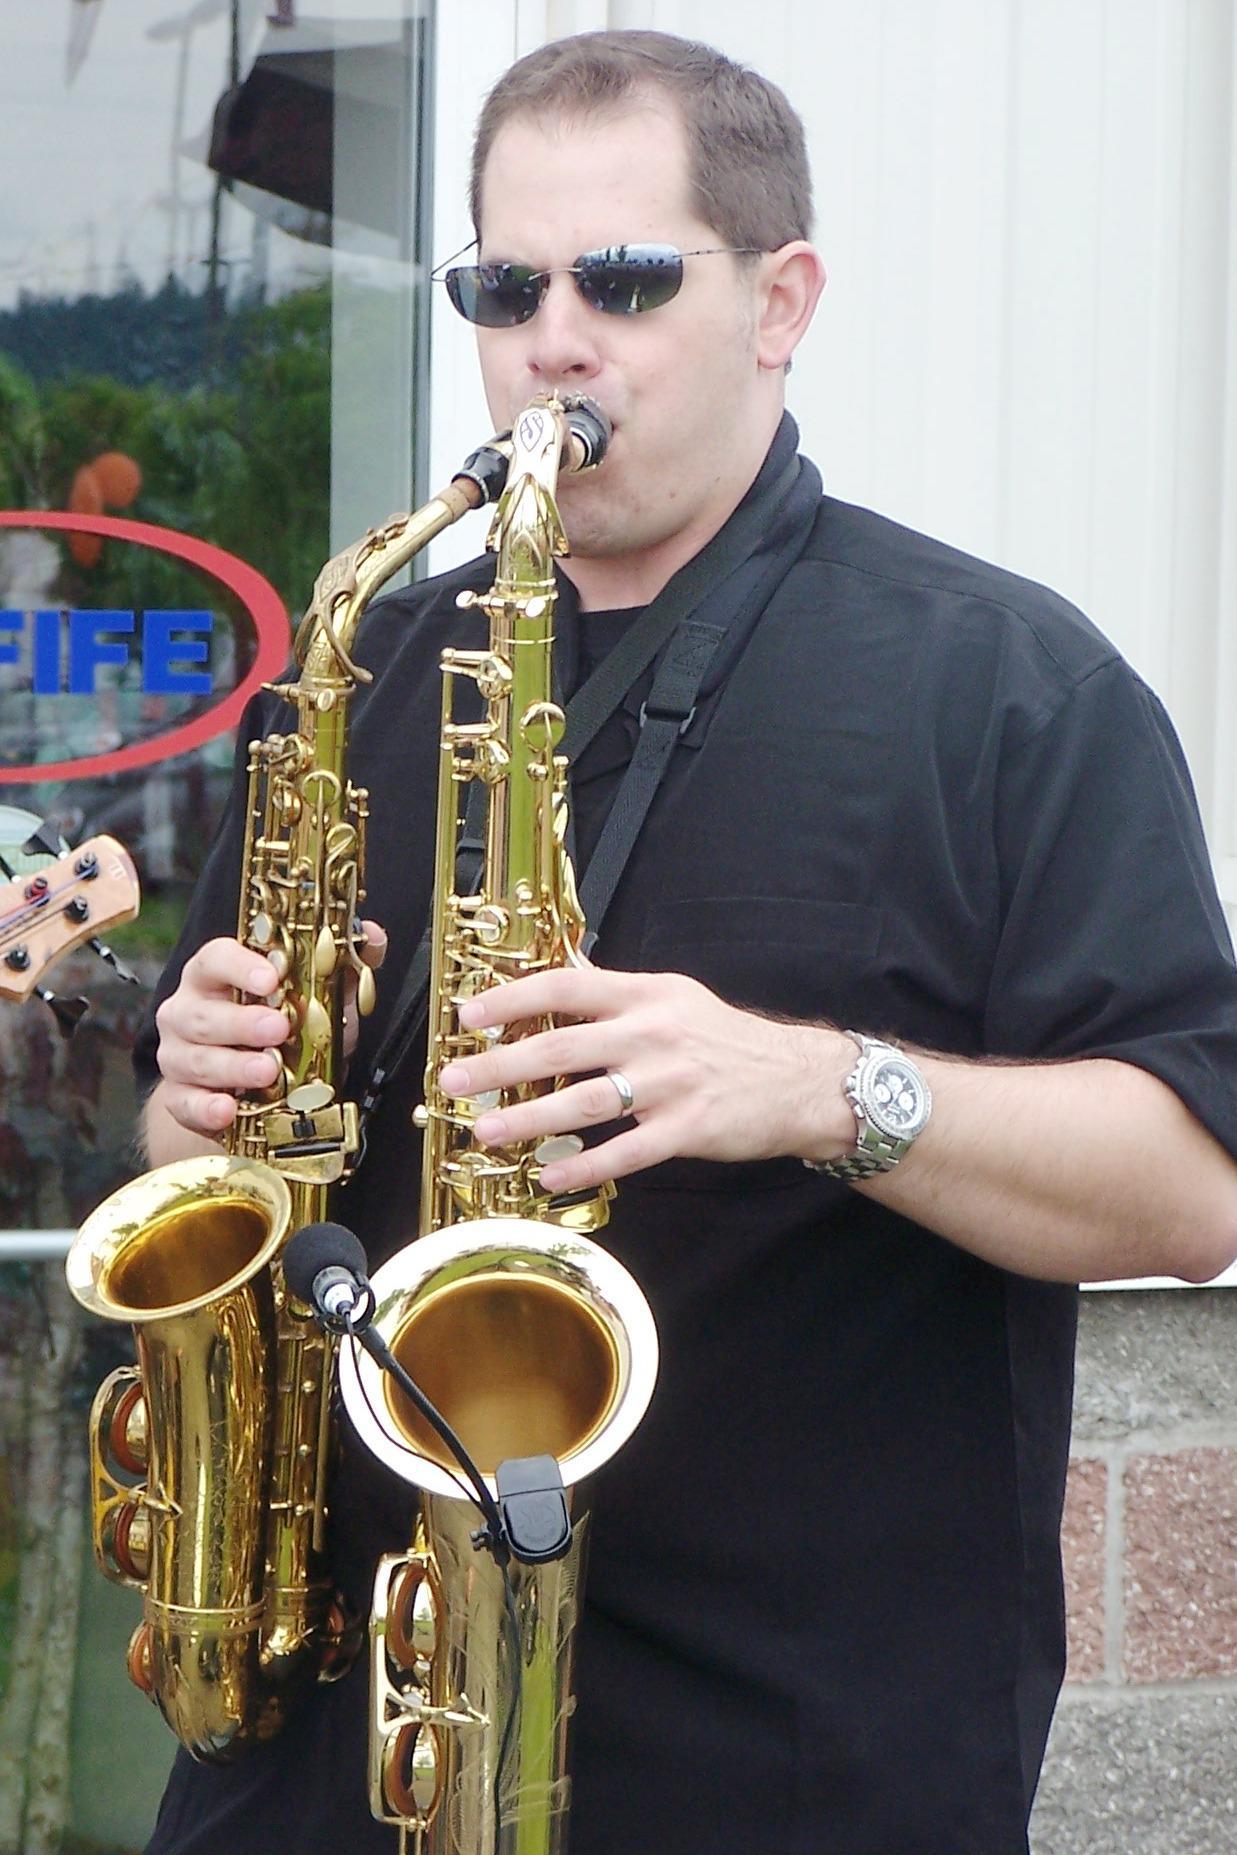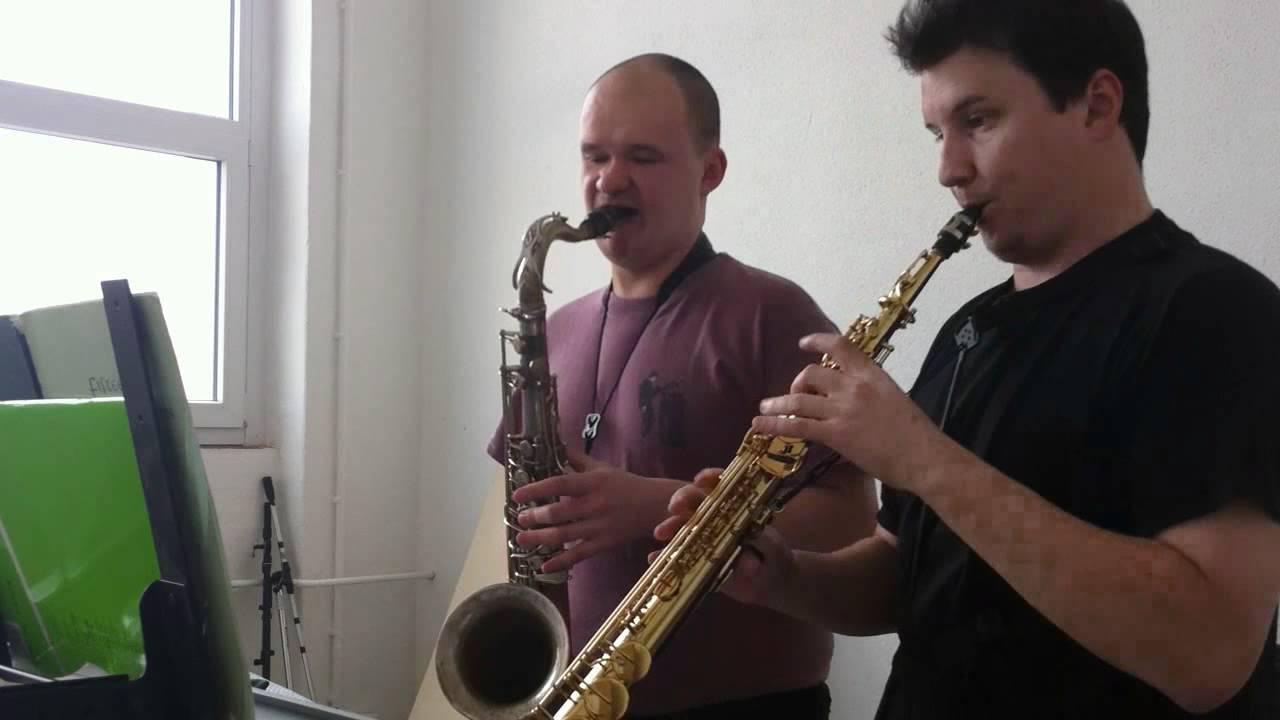The first image is the image on the left, the second image is the image on the right. Given the left and right images, does the statement "there is a bald ban holding an instrument with a bracelet  on and a short sleeved button down shirt" hold true? Answer yes or no. No. The first image is the image on the left, the second image is the image on the right. Considering the images on both sides, is "In one image, a man with a music stand near him sits and plays a guitar while another person wearing glasses is playing at least one saxophone." valid? Answer yes or no. No. The first image is the image on the left, the second image is the image on the right. For the images displayed, is the sentence "An image shows two men side-by-side holding instruments, and at least one of them wears a black short-sleeved t-shirt." factually correct? Answer yes or no. Yes. The first image is the image on the left, the second image is the image on the right. Given the left and right images, does the statement "A man is holding two saxophones in the image on the left." hold true? Answer yes or no. Yes. 